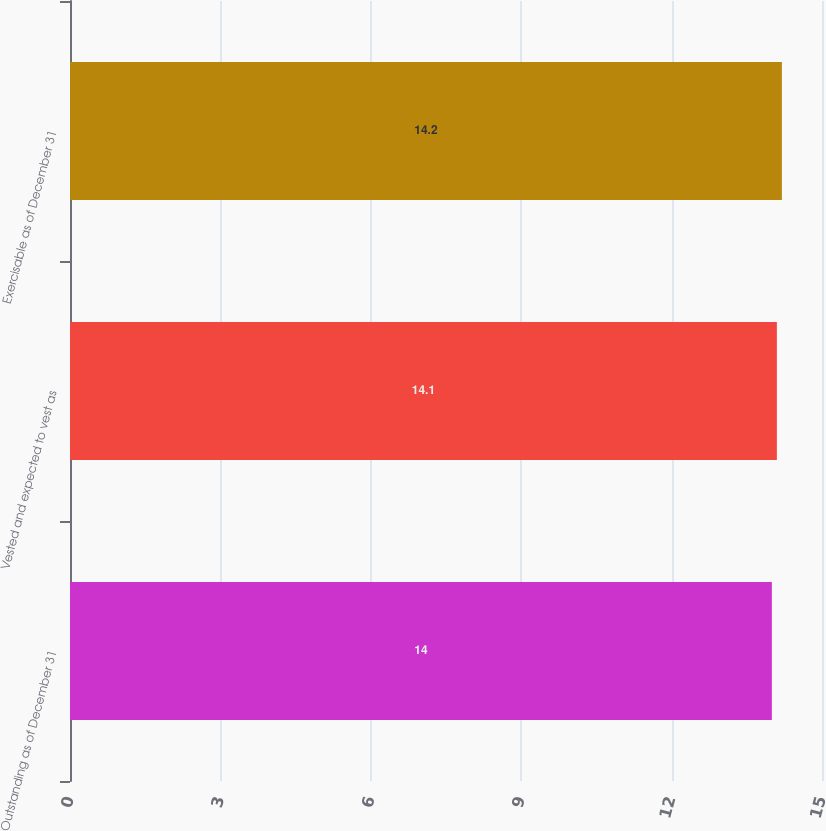<chart> <loc_0><loc_0><loc_500><loc_500><bar_chart><fcel>Outstanding as of December 31<fcel>Vested and expected to vest as<fcel>Exercisable as of December 31<nl><fcel>14<fcel>14.1<fcel>14.2<nl></chart> 